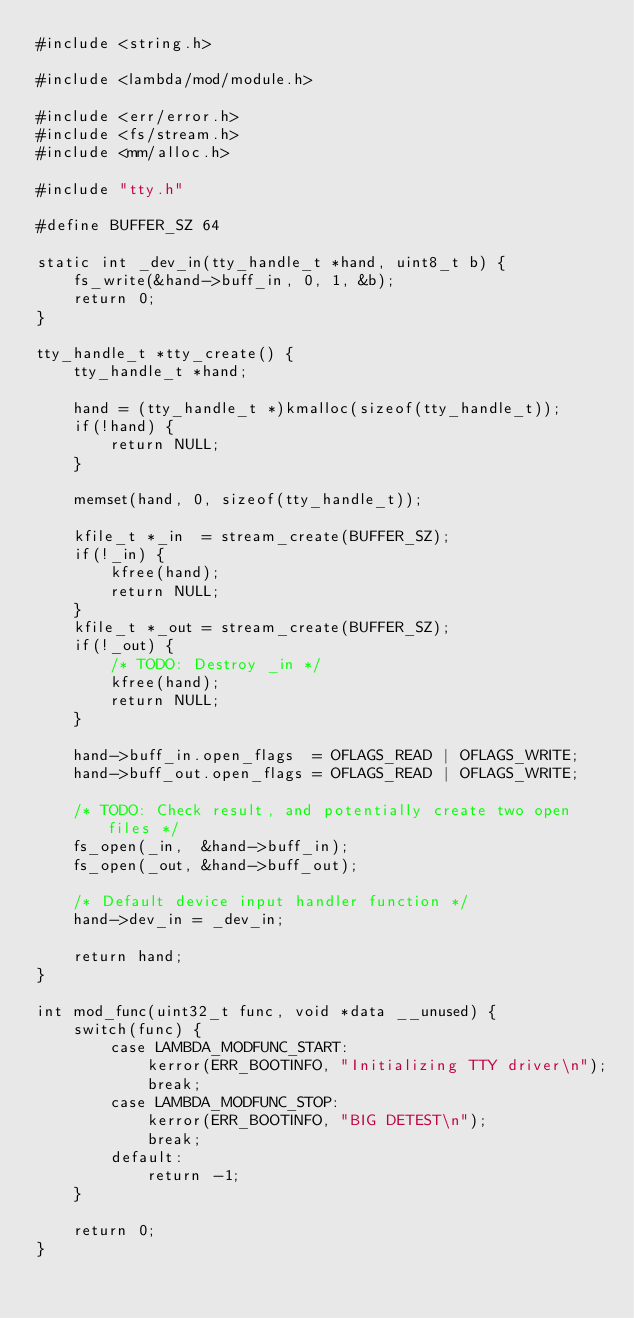<code> <loc_0><loc_0><loc_500><loc_500><_C_>#include <string.h>

#include <lambda/mod/module.h>

#include <err/error.h>
#include <fs/stream.h>
#include <mm/alloc.h>

#include "tty.h"

#define BUFFER_SZ 64

static int _dev_in(tty_handle_t *hand, uint8_t b) {
    fs_write(&hand->buff_in, 0, 1, &b);
    return 0;
}

tty_handle_t *tty_create() {
    tty_handle_t *hand;

    hand = (tty_handle_t *)kmalloc(sizeof(tty_handle_t));
    if(!hand) {
        return NULL;
    }

    memset(hand, 0, sizeof(tty_handle_t));

    kfile_t *_in  = stream_create(BUFFER_SZ);
    if(!_in) {
        kfree(hand);
        return NULL;
    }
    kfile_t *_out = stream_create(BUFFER_SZ);
    if(!_out) {
        /* TODO: Destroy _in */
        kfree(hand);
        return NULL;
    }

    hand->buff_in.open_flags  = OFLAGS_READ | OFLAGS_WRITE;
    hand->buff_out.open_flags = OFLAGS_READ | OFLAGS_WRITE;

    /* TODO: Check result, and potentially create two open files */
    fs_open(_in,  &hand->buff_in);
    fs_open(_out, &hand->buff_out);

    /* Default device input handler function */
    hand->dev_in = _dev_in;

    return hand;
}

int mod_func(uint32_t func, void *data __unused) {
    switch(func) {
        case LAMBDA_MODFUNC_START:
            kerror(ERR_BOOTINFO, "Initializing TTY driver\n");
            break;
        case LAMBDA_MODFUNC_STOP:
            kerror(ERR_BOOTINFO, "BIG DETEST\n");
            break;
        default:
            return -1;
    }

    return 0;
}
</code> 